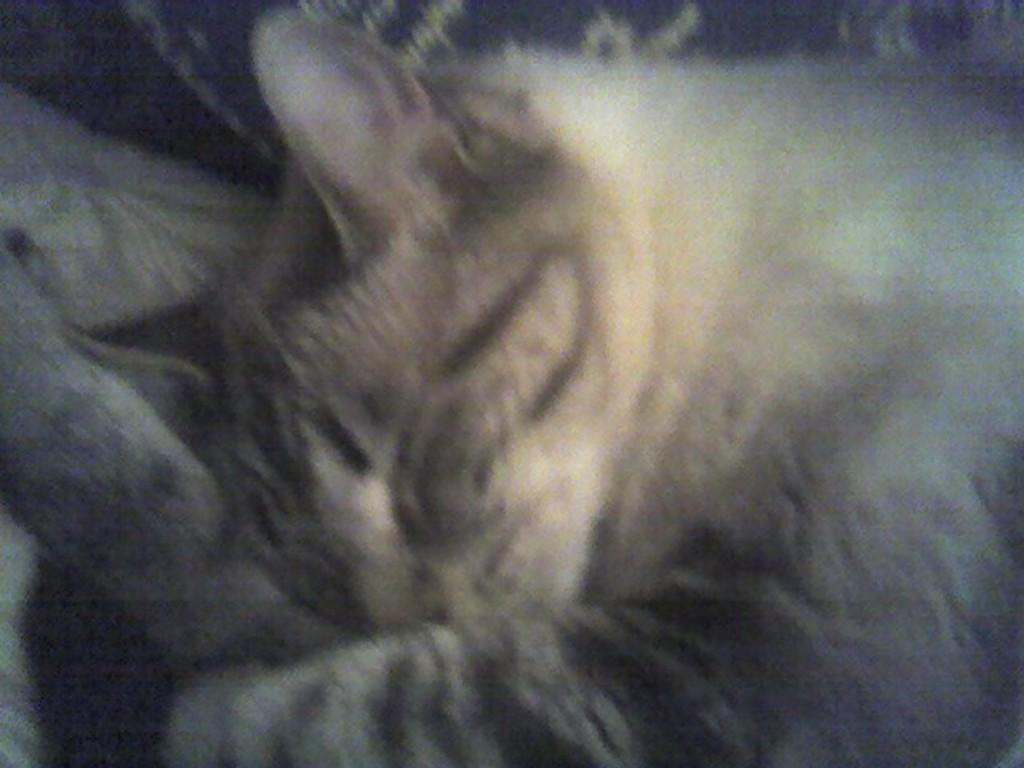In one or two sentences, can you explain what this image depicts? This is a blurred image of a sleeping cat. 